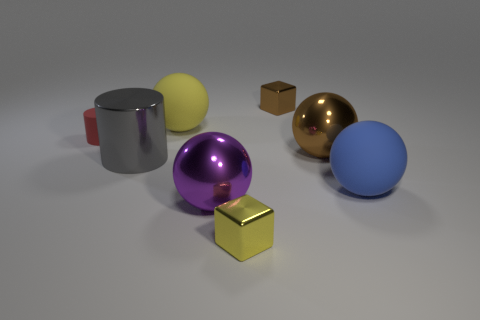Subtract all large blue matte balls. How many balls are left? 3 Subtract all blocks. How many objects are left? 6 Subtract 4 balls. How many balls are left? 0 Add 2 brown shiny balls. How many objects exist? 10 Subtract all red blocks. How many green cylinders are left? 0 Subtract all cyan metallic spheres. Subtract all yellow matte things. How many objects are left? 7 Add 8 gray shiny things. How many gray shiny things are left? 9 Add 5 cubes. How many cubes exist? 7 Subtract all purple spheres. How many spheres are left? 3 Subtract 0 cyan spheres. How many objects are left? 8 